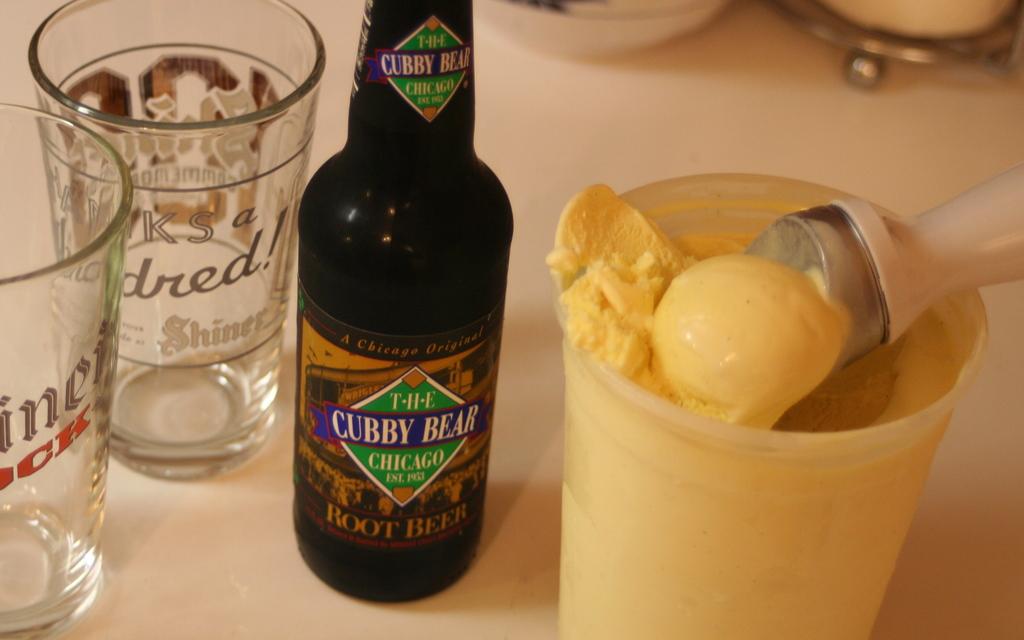Is this root beer?
Ensure brevity in your answer.  Yes. 